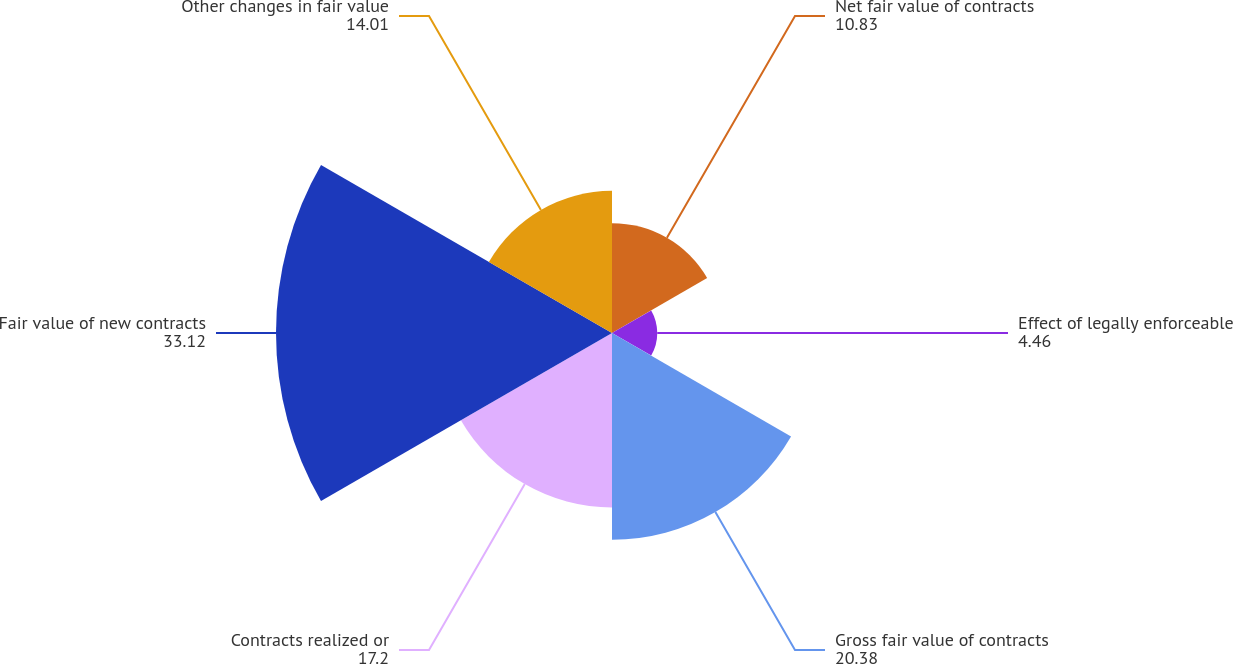Convert chart to OTSL. <chart><loc_0><loc_0><loc_500><loc_500><pie_chart><fcel>Net fair value of contracts<fcel>Effect of legally enforceable<fcel>Gross fair value of contracts<fcel>Contracts realized or<fcel>Fair value of new contracts<fcel>Other changes in fair value<nl><fcel>10.83%<fcel>4.46%<fcel>20.38%<fcel>17.2%<fcel>33.12%<fcel>14.01%<nl></chart> 